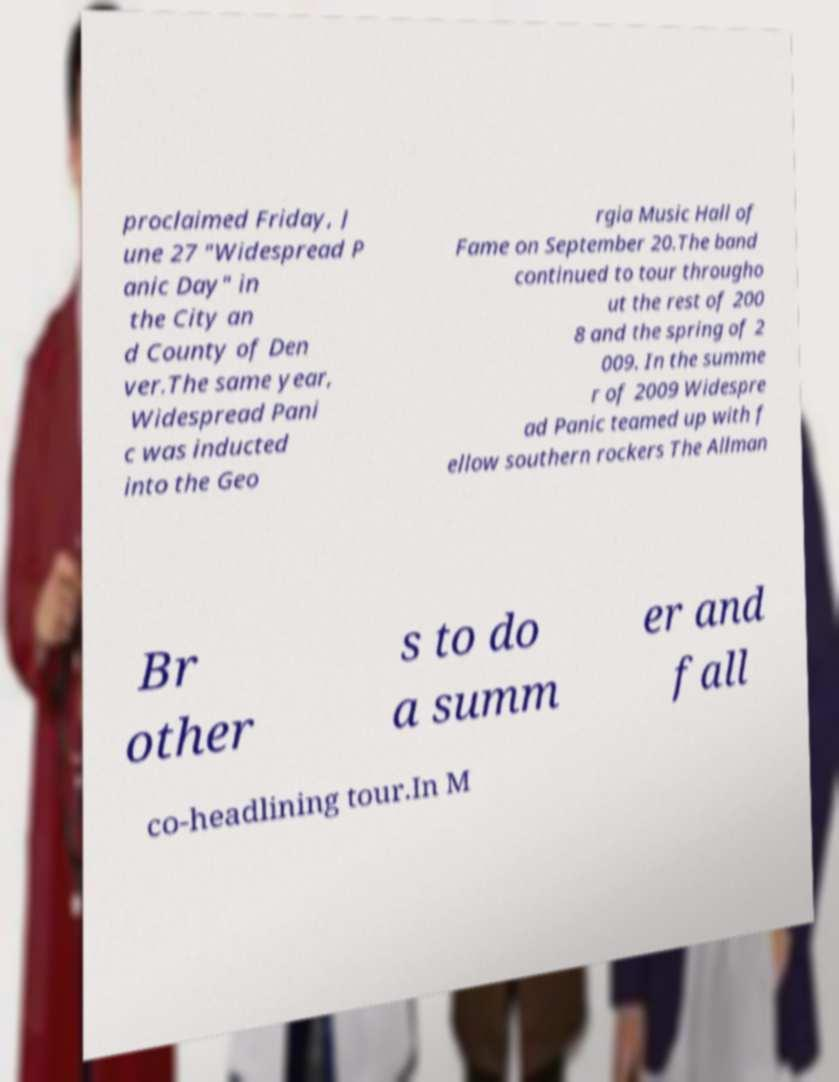Please read and relay the text visible in this image. What does it say? proclaimed Friday, J une 27 "Widespread P anic Day" in the City an d County of Den ver.The same year, Widespread Pani c was inducted into the Geo rgia Music Hall of Fame on September 20.The band continued to tour througho ut the rest of 200 8 and the spring of 2 009. In the summe r of 2009 Widespre ad Panic teamed up with f ellow southern rockers The Allman Br other s to do a summ er and fall co-headlining tour.In M 